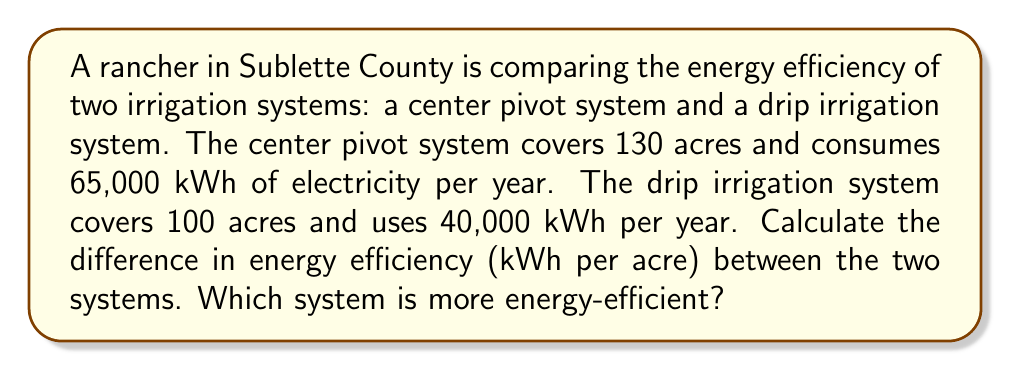Show me your answer to this math problem. 1. Calculate the energy efficiency of the center pivot system:
   $$E_{cp} = \frac{\text{Energy consumed}}{\text{Area covered}} = \frac{65,000 \text{ kWh}}{130 \text{ acres}} = 500 \text{ kWh/acre}$$

2. Calculate the energy efficiency of the drip irrigation system:
   $$E_{drip} = \frac{\text{Energy consumed}}{\text{Area covered}} = \frac{40,000 \text{ kWh}}{100 \text{ acres}} = 400 \text{ kWh/acre}$$

3. Calculate the difference in energy efficiency:
   $$\Delta E = E_{cp} - E_{drip} = 500 \text{ kWh/acre} - 400 \text{ kWh/acre} = 100 \text{ kWh/acre}$$

4. Determine which system is more energy-efficient:
   The system with the lower energy consumption per acre is more efficient. In this case, the drip irrigation system uses 400 kWh/acre, which is less than the center pivot system's 500 kWh/acre.
Answer: 100 kWh/acre; drip irrigation 